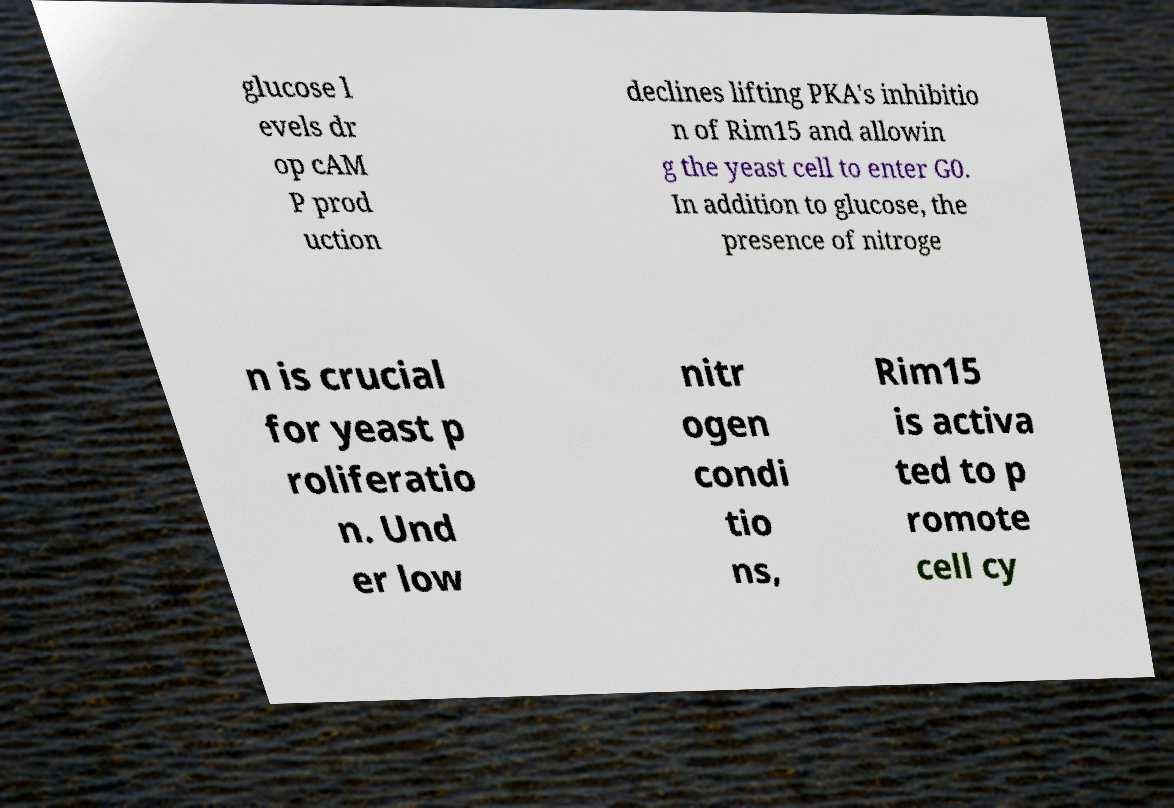Could you extract and type out the text from this image? glucose l evels dr op cAM P prod uction declines lifting PKA's inhibitio n of Rim15 and allowin g the yeast cell to enter G0. In addition to glucose, the presence of nitroge n is crucial for yeast p roliferatio n. Und er low nitr ogen condi tio ns, Rim15 is activa ted to p romote cell cy 